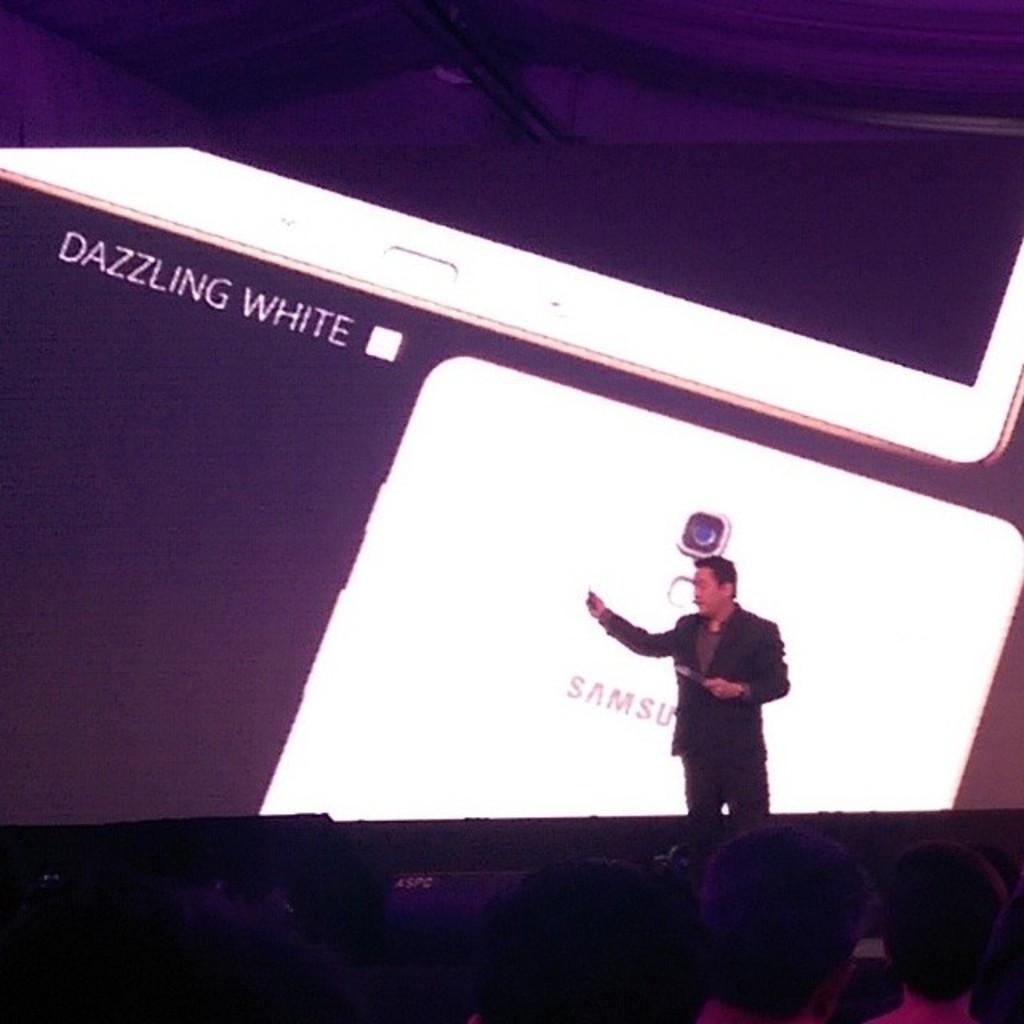What is the person in the image doing? The person is standing on a stage. Where is the person located in the image? The person is on the right side of the image. What is happening in front of the person on the stage? There are people in front of the person on the stage. What can be seen in the background of the image? There is a screen in the background of the image. What type of wool is being spun on the stage in the image? There is no wool or spinning activity present in the image. How many roses are being held by the person on the stage? There are no roses visible in the image. 